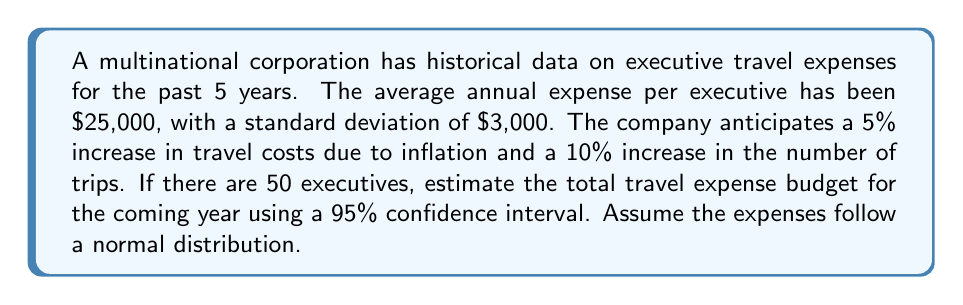What is the answer to this math problem? To solve this problem, we'll follow these steps:

1. Calculate the projected average expense per executive:
   $25,000 * 1.05 = $26,250$ (5% increase due to inflation)

2. Calculate the projected total expense for all executives:
   $26,250 * 50 * 1.10 = $1,443,750$ (including 10% increase in trips)

3. Calculate the standard error of the mean:
   $SE = \frac{\sigma}{\sqrt{n}} = \frac{3,000}{\sqrt{50}} = 424.26$

4. Find the z-score for a 95% confidence interval:
   For a 95% CI, z = 1.96

5. Calculate the margin of error:
   $ME = z * SE * 1.05 * 1.10$
   $ME = 1.96 * 424.26 * 1.05 * 1.10 = 956.77$

6. Calculate the confidence interval:
   Lower bound: $1,443,750 - 956.77 = $1,442,793.23$
   Upper bound: $1,443,750 + 956.77 = $1,444,706.77$

The 95% confidence interval for the total travel expense budget is:

$$[$1,442,793.23, $1,444,706.77]$$

This means we can be 95% confident that the true total travel expense budget for the coming year will fall within this range.
Answer: The estimated total travel expense budget for the coming year, with a 95% confidence interval, is [$1,442,793.23, $1,444,706.77]. 